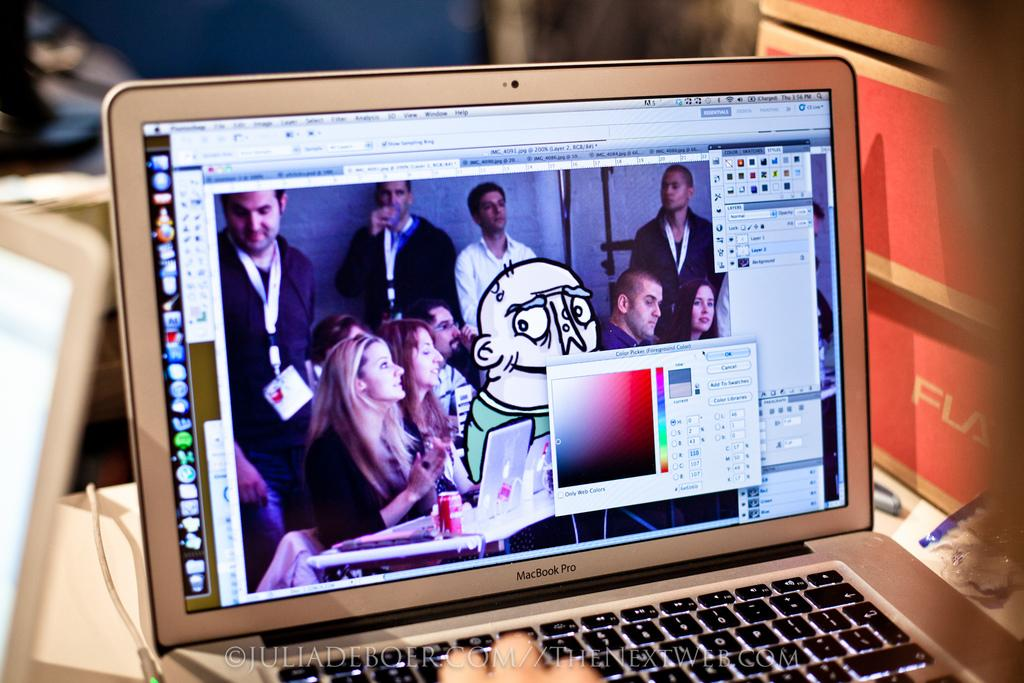<image>
Relay a brief, clear account of the picture shown. Someone is working on art graphics using a Macbook Pro. 